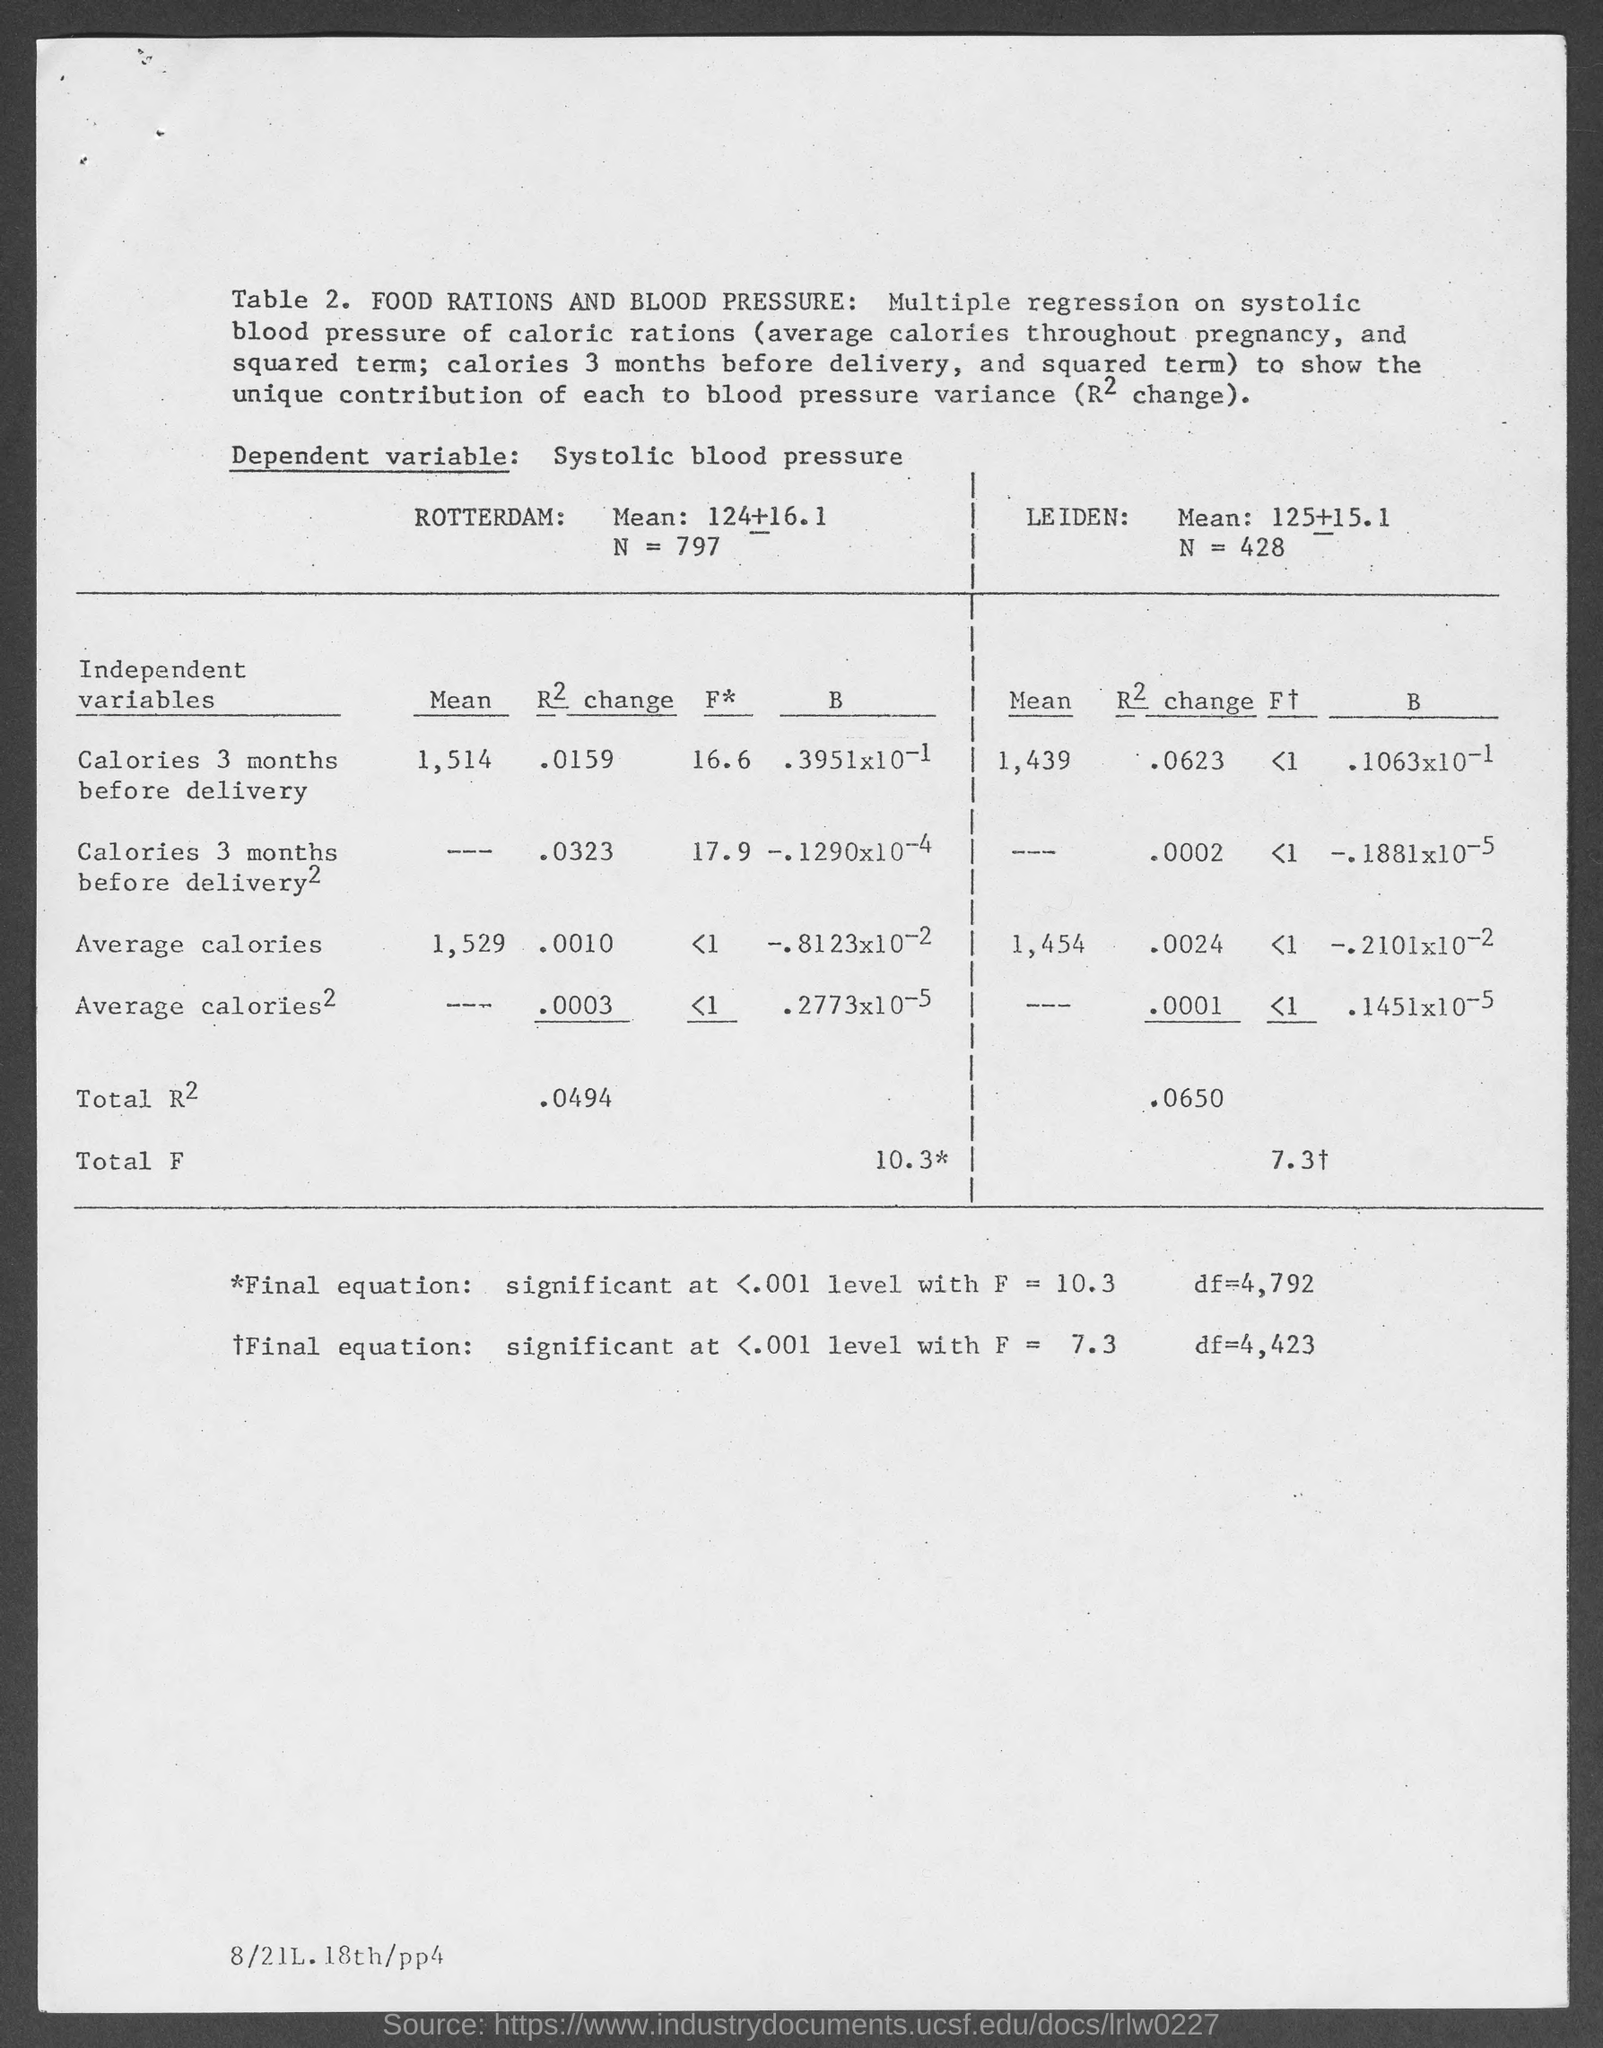Draw attention to some important aspects in this diagram. The mean caloric intake for women in Leiden three months prior to delivery was 1,439 calories per day. The R2 change for calories 3 months before delivery for Rotterdam is 0.0159. The mean caloric intake for women in Rotterdam three months before delivery was 1,514 calories per day. The R2 Change for calories 3 months before delivery for Leiden is 0.0623. 